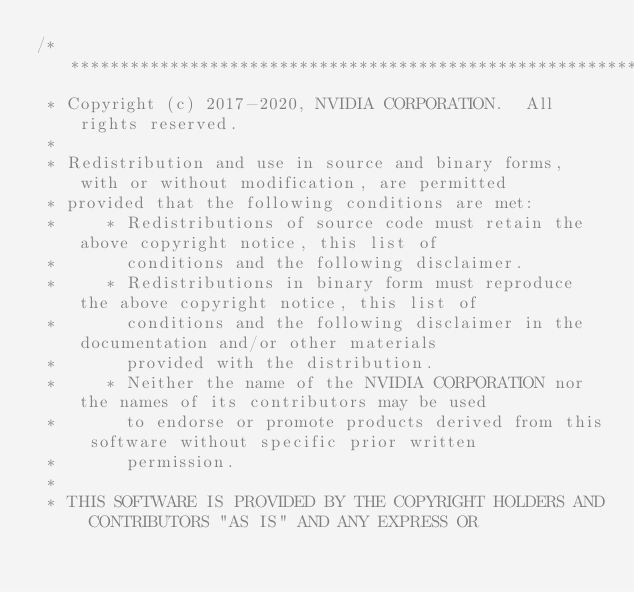Convert code to text. <code><loc_0><loc_0><loc_500><loc_500><_Cuda_>/***************************************************************************************************
 * Copyright (c) 2017-2020, NVIDIA CORPORATION.  All rights reserved.
 *
 * Redistribution and use in source and binary forms, with or without modification, are permitted
 * provided that the following conditions are met:
 *     * Redistributions of source code must retain the above copyright notice, this list of
 *       conditions and the following disclaimer.
 *     * Redistributions in binary form must reproduce the above copyright notice, this list of
 *       conditions and the following disclaimer in the documentation and/or other materials
 *       provided with the distribution.
 *     * Neither the name of the NVIDIA CORPORATION nor the names of its contributors may be used
 *       to endorse or promote products derived from this software without specific prior written
 *       permission.
 *
 * THIS SOFTWARE IS PROVIDED BY THE COPYRIGHT HOLDERS AND CONTRIBUTORS "AS IS" AND ANY EXPRESS OR</code> 